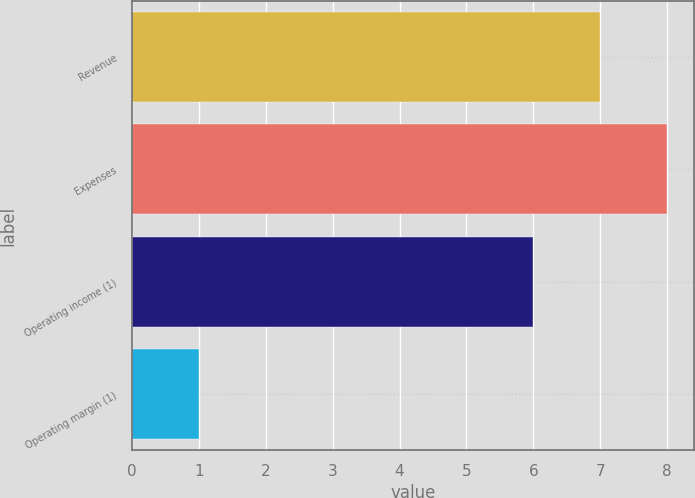<chart> <loc_0><loc_0><loc_500><loc_500><bar_chart><fcel>Revenue<fcel>Expenses<fcel>Operating income (1)<fcel>Operating margin (1)<nl><fcel>7<fcel>8<fcel>6<fcel>1<nl></chart> 